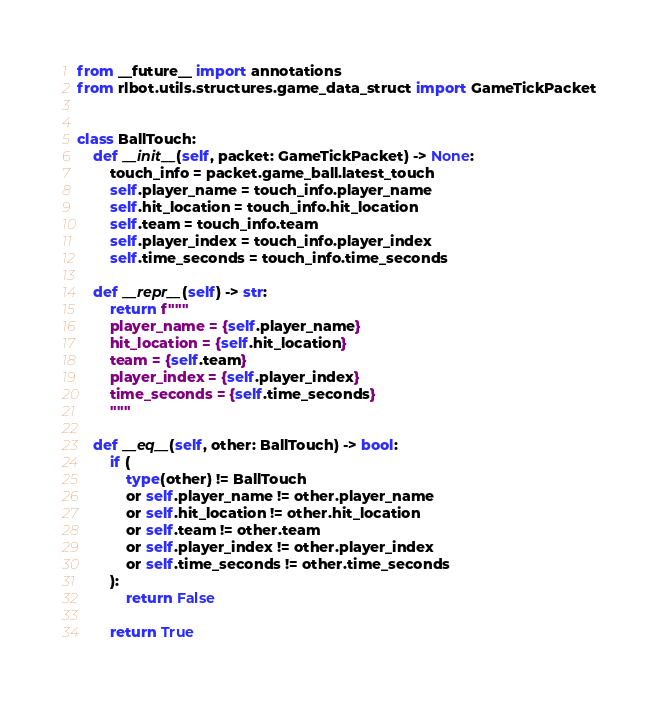Convert code to text. <code><loc_0><loc_0><loc_500><loc_500><_Python_>from __future__ import annotations
from rlbot.utils.structures.game_data_struct import GameTickPacket


class BallTouch:
    def __init__(self, packet: GameTickPacket) -> None:
        touch_info = packet.game_ball.latest_touch
        self.player_name = touch_info.player_name
        self.hit_location = touch_info.hit_location
        self.team = touch_info.team
        self.player_index = touch_info.player_index
        self.time_seconds = touch_info.time_seconds

    def __repr__(self) -> str:
        return f"""
        player_name = {self.player_name}
        hit_location = {self.hit_location}
        team = {self.team}
        player_index = {self.player_index}
        time_seconds = {self.time_seconds}
        """

    def __eq__(self, other: BallTouch) -> bool:
        if (
            type(other) != BallTouch
            or self.player_name != other.player_name
            or self.hit_location != other.hit_location
            or self.team != other.team
            or self.player_index != other.player_index
            or self.time_seconds != other.time_seconds
        ):
            return False

        return True
</code> 